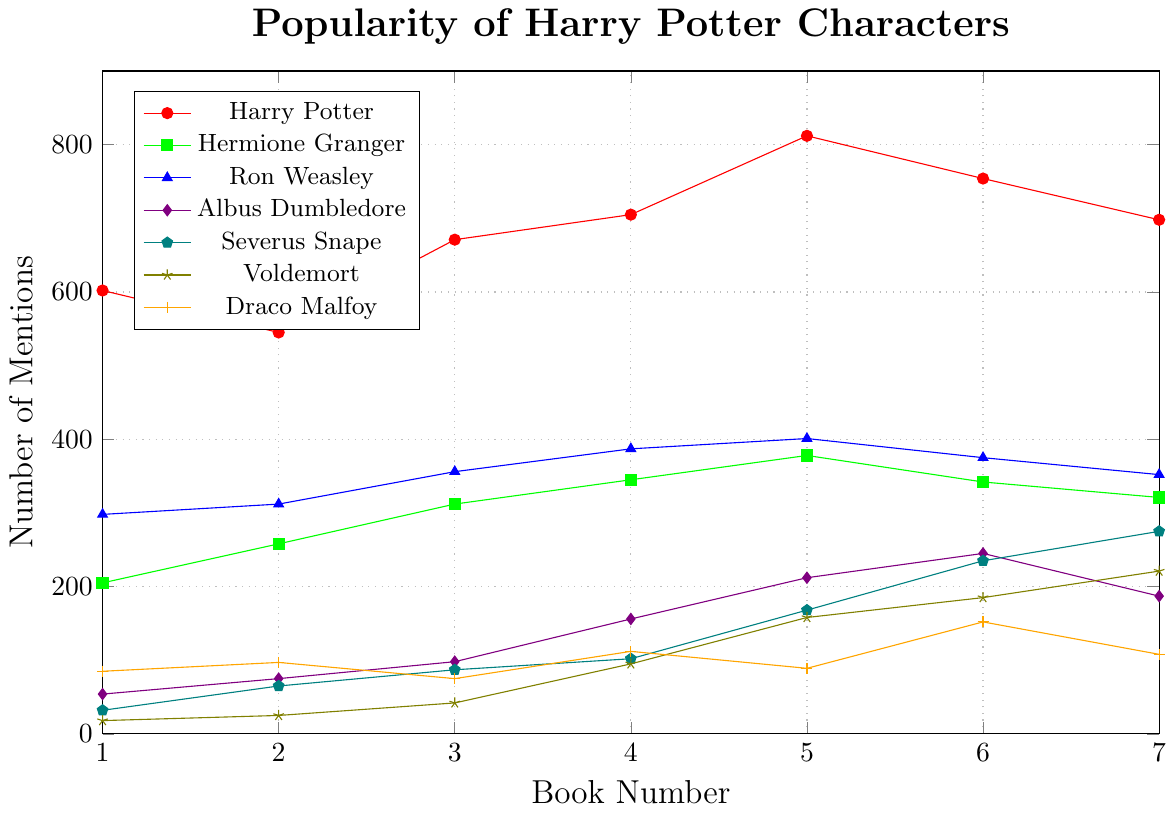Which character has the most mentions in Book 4? From the figure, evaluate each character's number of mentions in Book 4. Harry Potter has the highest value with 705 mentions.
Answer: Harry Potter What is the difference in mentions between Severus Snape and Voldemort in Book 7? Find the mentions for Severus Snape and Voldemort in Book 7 (275 and 221 respectively). Then, subtract Voldemort's mentions from Severus Snape's mentions (275 - 221 = 54).
Answer: 54 Which character experiences the greatest increase in mentions from Book 1 to Book 7? Calculate the differences in mentions from Book 1 to Book 7 for each character. Harry Potter begins with 602 and ends with 698 (an increase of 96), but Severus Snape starts with 32 and ends with 275 (an increase of 243). Snape has the greatest increase.
Answer: Severus Snape What is the average number of mentions for Hermione Granger across all books? Add mentions across all books for Hermione Granger (205 + 258 + 312 + 345 + 378 + 342 + 321) to get 2161. Divide this total by 7 (2161 / 7 ≈ 308.71).
Answer: 308.71 How do the total mentions of Ron Weasley in Books 1 and 7 compare to those of Hermione Granger in the same books? Compare Ron Weasley's total mentions in Books 1 and 7 (298 + 352 = 650) to Hermione Granger's (205 + 321 = 526). Ron Weasley has more mentions.
Answer: Ron Weasley Which book has the highest number of mentions for Albus Dumbledore? From the figure, notice that Book 6 has the highest number of mentions for Albus Dumbledore, at 245.
Answer: Book 6 Do Harry Potter's mentions increase or decrease from Book 5 to Book 7? Observe Harry Potter's mentions in Books 5, 6, and 7 (812, 754, 698). Notice the decrease from 812 to 754, and again to 698.
Answer: Decrease Which book sees a significant increase in mentions for Voldemort compared to previous books? In Book 4, Voldemort's mentions surge from 42 in Book 3 to 95 in Book 4. This pattern continues with a steady rise in subsequent books, but Book 4 marks the most significant jump.
Answer: Book 4 What is the trend of mentions for Hermione Granger from Book 4 to Book 7? Analyze the data points for Hermione Granger in Books 4, 5, 6, and 7 (345, 378, 342, 321). There is a slight increase from Book 4 to 5 but then a decrease in Books 6 and 7.
Answer: Decreasing trend 